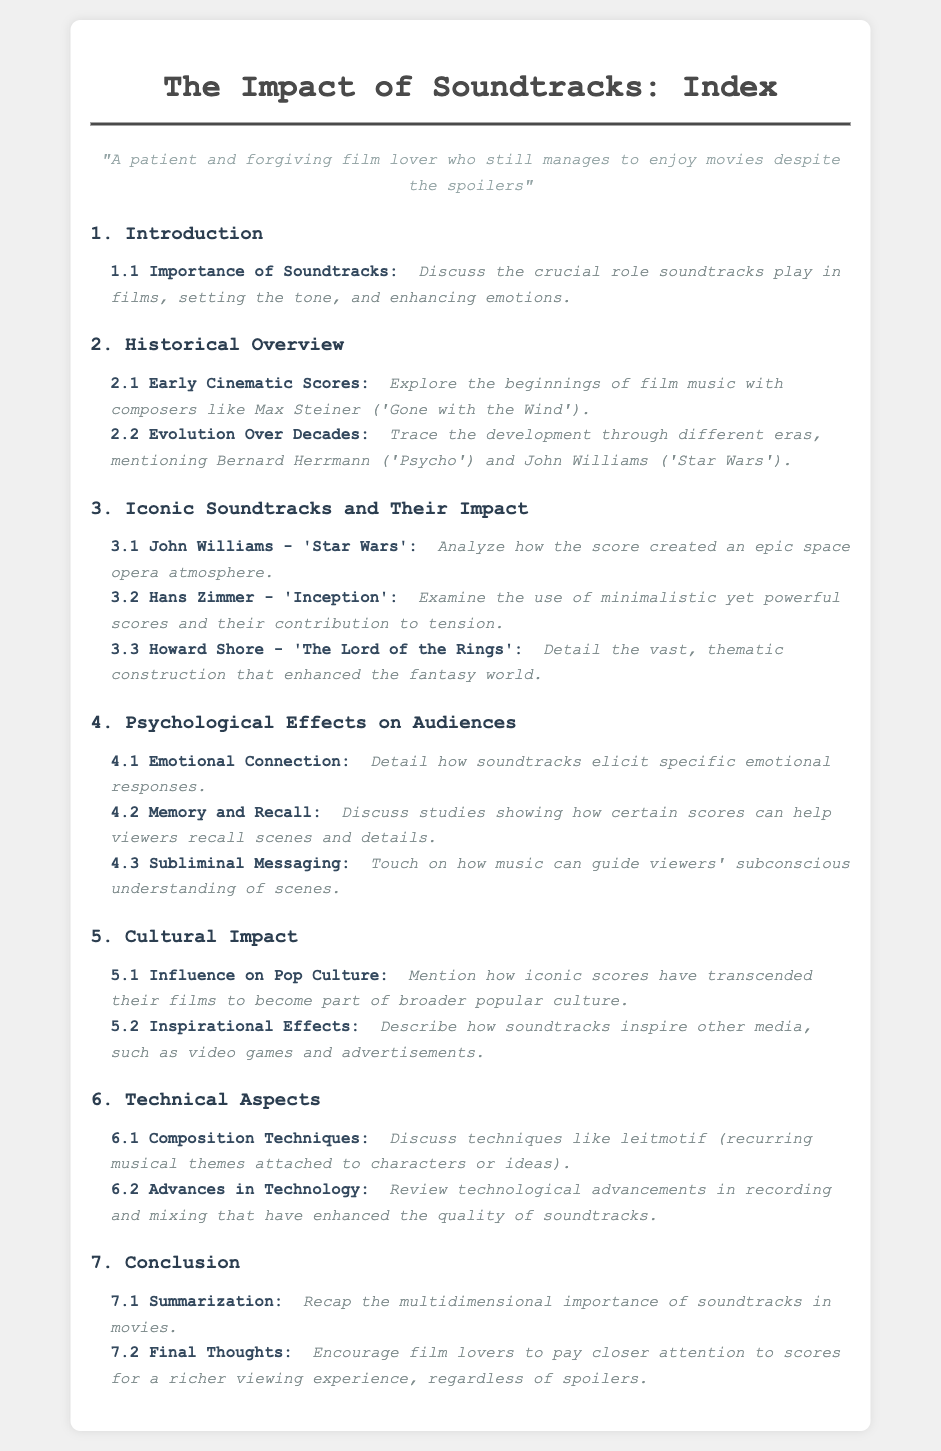What is the role of soundtracks in films? The document states that soundtracks play a crucial role in setting the tone and enhancing emotions.
Answer: crucial role Who composed the score for 'Gone with the Wind'? The document mentions Max Steiner as the composer for 'Gone with the Wind'.
Answer: Max Steiner Which iconic score is analyzed for creating an epic space opera atmosphere? The document refers to John Williams' score for 'Star Wars' as creating an epic space opera atmosphere.
Answer: 'Star Wars' What technique is discussed in the context of composition? The document highlights the technique of leitmotif, which involves recurring musical themes.
Answer: leitmotif How do soundtracks affect emotional connection according to the document? The document suggests that soundtracks elicit specific emotional responses, indicating their influence on emotional connection.
Answer: elicit specific emotional responses What is one effect of iconic scores on popular culture? The document mentions that iconic scores can transcend their films to become part of broader popular culture.
Answer: transcend their films Who composed the score for 'Inception'? The composer of the score for 'Inception', as stated in the document, is Hans Zimmer.
Answer: Hans Zimmer Which section discusses the advances in recording technology? The advances in technology related to recording and mixing are discussed in the section titled "Technical Aspects."
Answer: Technical Aspects What is encouraged in the final thoughts of the document? The final thoughts encourage film lovers to pay closer attention to scores for a richer viewing experience.
Answer: pay closer attention to scores 